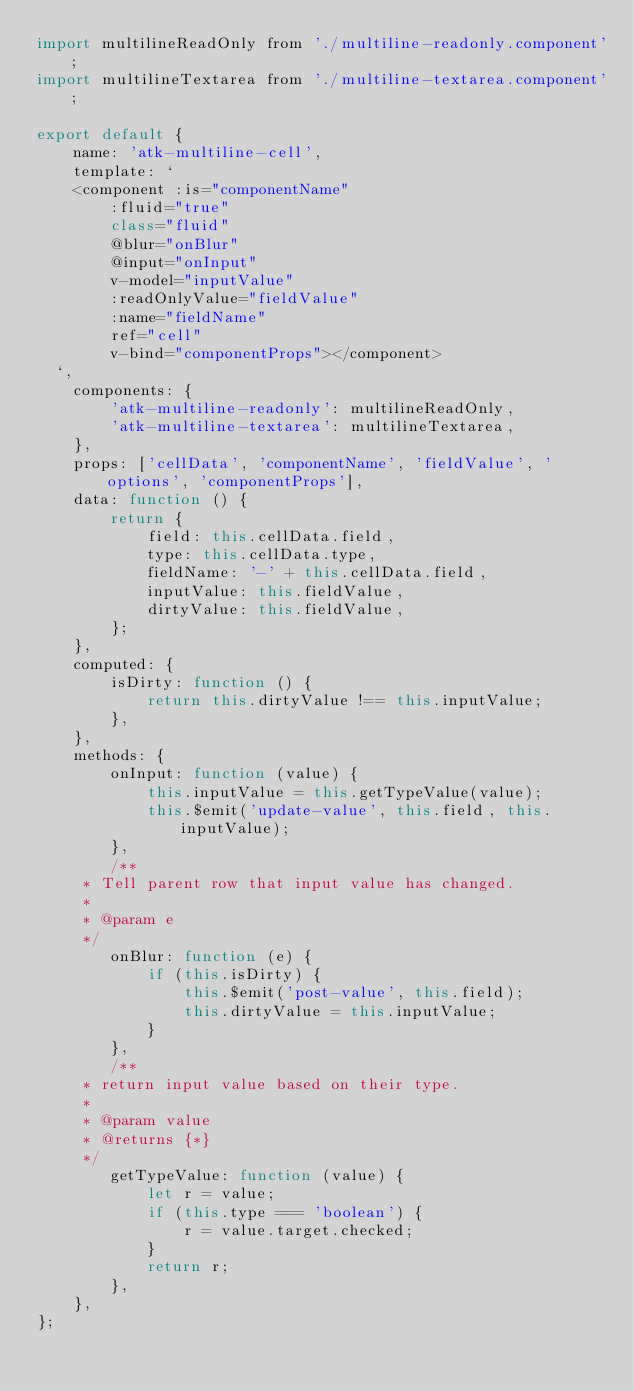Convert code to text. <code><loc_0><loc_0><loc_500><loc_500><_JavaScript_>import multilineReadOnly from './multiline-readonly.component';
import multilineTextarea from './multiline-textarea.component';

export default {
    name: 'atk-multiline-cell',
    template: ` 
    <component :is="componentName"
        :fluid="true"  
        class="fluid" 
        @blur="onBlur"
        @input="onInput"
        v-model="inputValue"
        :readOnlyValue="fieldValue"
        :name="fieldName"
        ref="cell"
        v-bind="componentProps"></component>
  `,
    components: {
        'atk-multiline-readonly': multilineReadOnly,
        'atk-multiline-textarea': multilineTextarea,
    },
    props: ['cellData', 'componentName', 'fieldValue', 'options', 'componentProps'],
    data: function () {
        return {
            field: this.cellData.field,
            type: this.cellData.type,
            fieldName: '-' + this.cellData.field,
            inputValue: this.fieldValue,
            dirtyValue: this.fieldValue,
        };
    },
    computed: {
        isDirty: function () {
            return this.dirtyValue !== this.inputValue;
        },
    },
    methods: {
        onInput: function (value) {
            this.inputValue = this.getTypeValue(value);
            this.$emit('update-value', this.field, this.inputValue);
        },
        /**
     * Tell parent row that input value has changed.
     *
     * @param e
     */
        onBlur: function (e) {
            if (this.isDirty) {
                this.$emit('post-value', this.field);
                this.dirtyValue = this.inputValue;
            }
        },
        /**
     * return input value based on their type.
     *
     * @param value
     * @returns {*}
     */
        getTypeValue: function (value) {
            let r = value;
            if (this.type === 'boolean') {
                r = value.target.checked;
            }
            return r;
        },
    },
};
</code> 